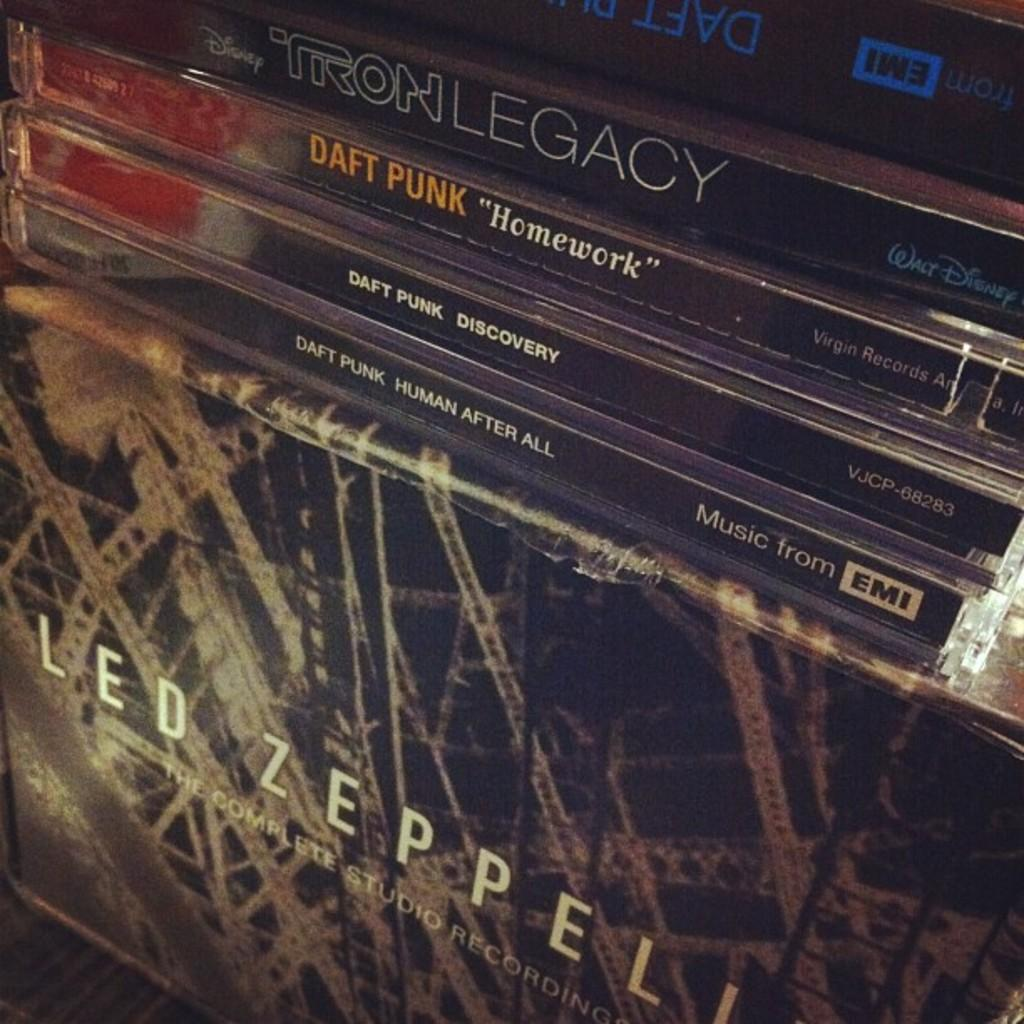Provide a one-sentence caption for the provided image. Some Compact Discs by Daft Punk on the Led Zeppelin's album. 